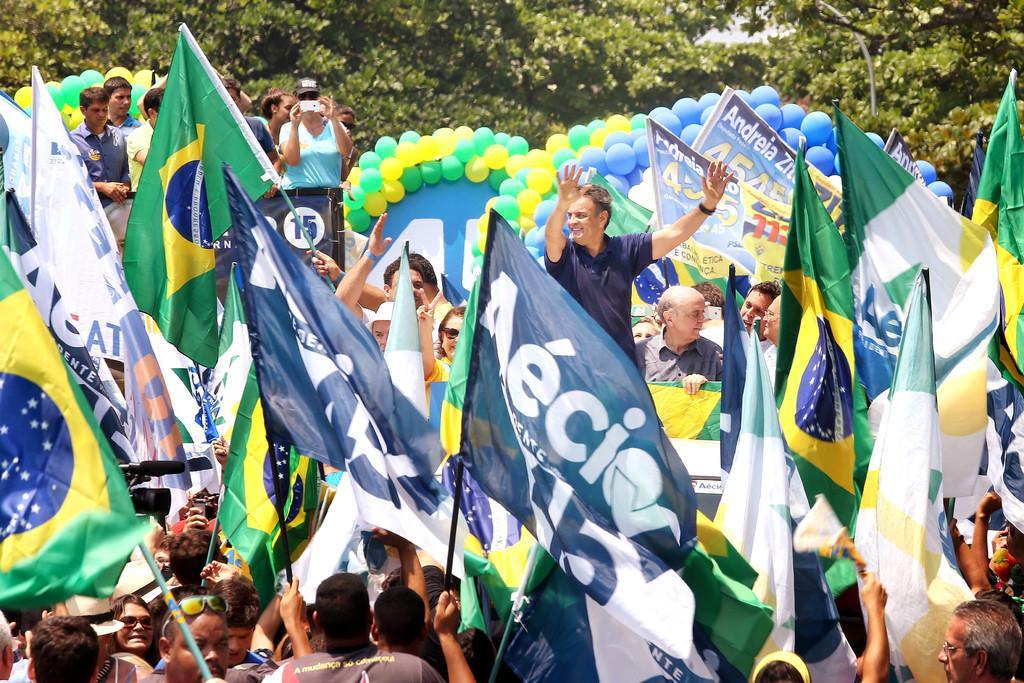Please provide a concise description of this image. In this picture we can see some people, some of them are holding flags, there are balloons and banners in the middle, in the background we can see trees. 